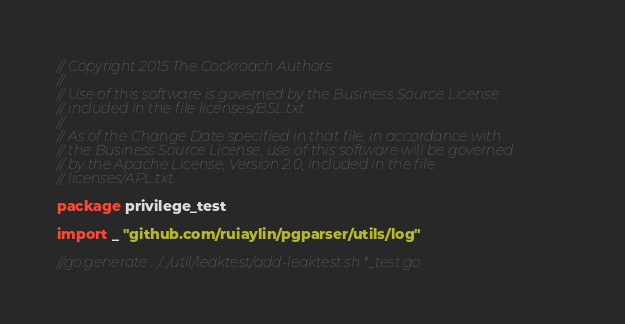<code> <loc_0><loc_0><loc_500><loc_500><_Go_>// Copyright 2015 The Cockroach Authors.
//
// Use of this software is governed by the Business Source License
// included in the file licenses/BSL.txt.
//
// As of the Change Date specified in that file, in accordance with
// the Business Source License, use of this software will be governed
// by the Apache License, Version 2.0, included in the file
// licenses/APL.txt.

package privilege_test

import _ "github.com/ruiaylin/pgparser/utils/log"

//go:generate ../../util/leaktest/add-leaktest.sh *_test.go
</code> 